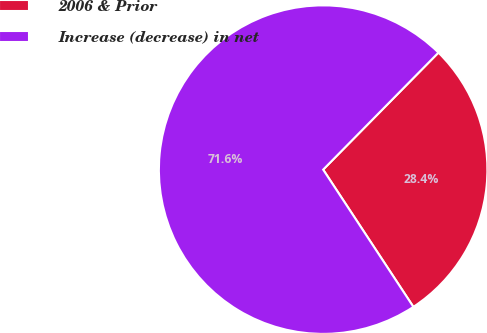Convert chart to OTSL. <chart><loc_0><loc_0><loc_500><loc_500><pie_chart><fcel>2006 & Prior<fcel>Increase (decrease) in net<nl><fcel>28.36%<fcel>71.64%<nl></chart> 